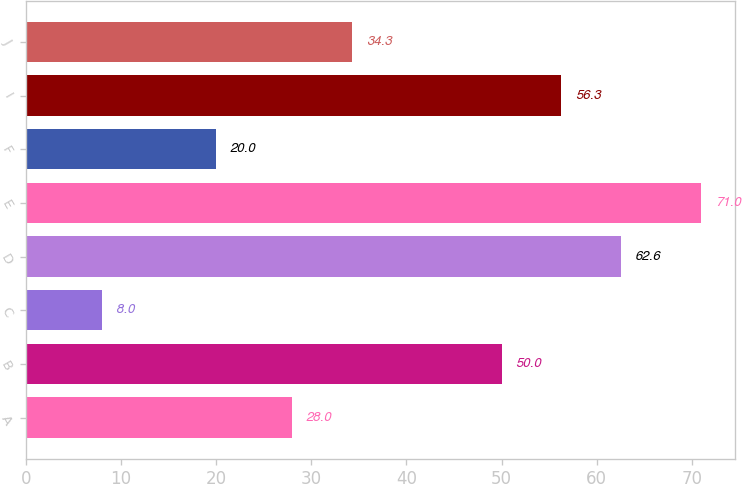Convert chart to OTSL. <chart><loc_0><loc_0><loc_500><loc_500><bar_chart><fcel>A<fcel>B<fcel>C<fcel>D<fcel>E<fcel>F<fcel>I<fcel>J<nl><fcel>28<fcel>50<fcel>8<fcel>62.6<fcel>71<fcel>20<fcel>56.3<fcel>34.3<nl></chart> 